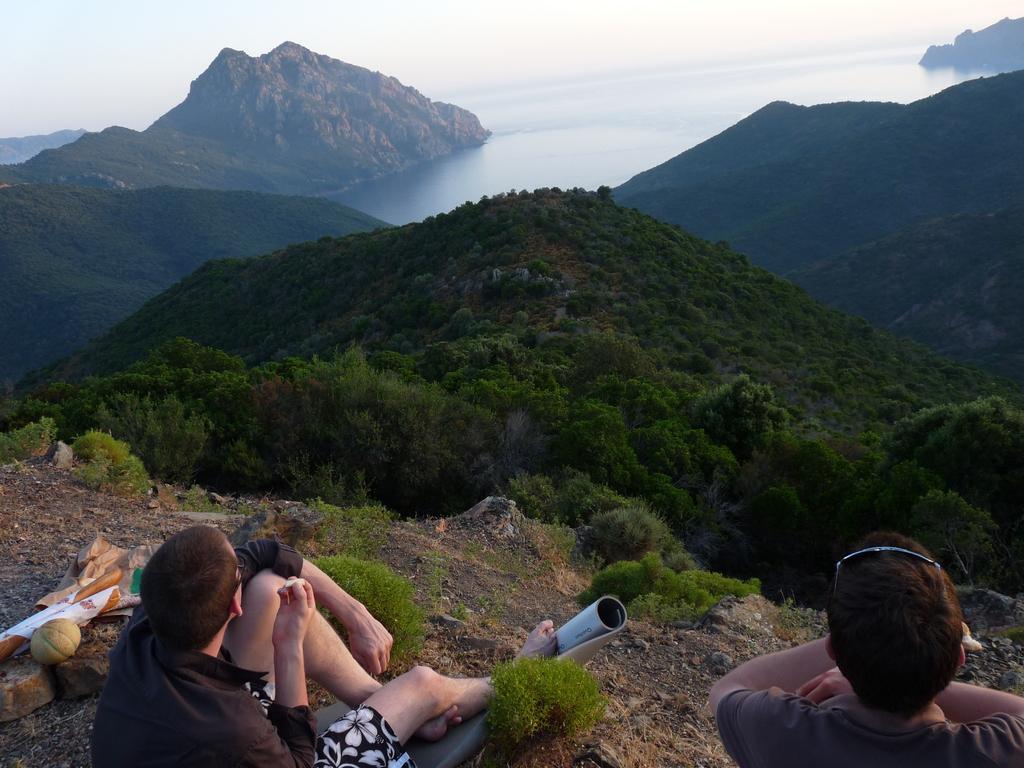In one or two sentences, can you explain what this image depicts? In this picture we can see few people, in front of them we can find few trees and hills. 